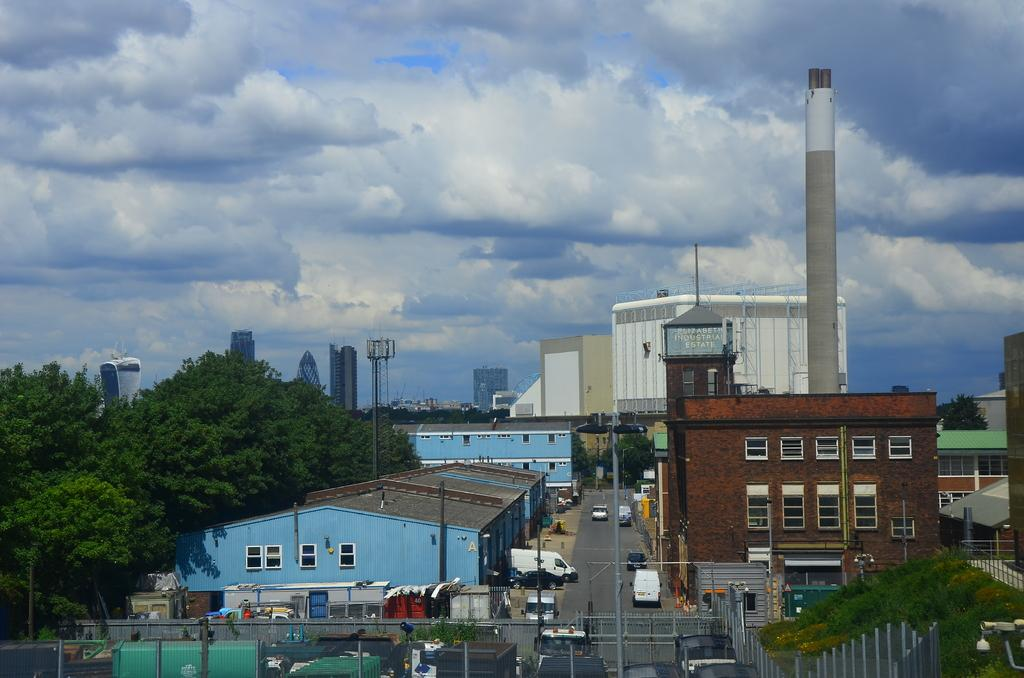What type of structures can be seen in the image? There are buildings in the image. What else can be seen moving in the image? There are vehicles in the image. What type of barriers are present in the image? There are fences in the image. What tall structures can be seen in the image? There are towers in the image. What vertical objects are present in the image? There are poles in the image. What type of vegetation is visible in the image? There are trees in the image. Where is the shirt hanging in the image? There is no shirt present in the image. What type of underground space can be seen in the image? There is no cellar present in the image. 